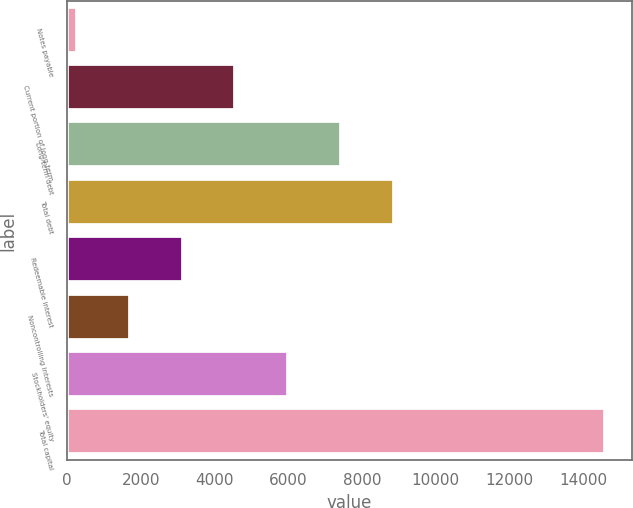<chart> <loc_0><loc_0><loc_500><loc_500><bar_chart><fcel>Notes payable<fcel>Current portion of long-term<fcel>Long-term debt<fcel>Total debt<fcel>Redeemable interest<fcel>Noncontrolling interests<fcel>Stockholders' equity<fcel>Total capital<nl><fcel>269.8<fcel>4563.94<fcel>7426.7<fcel>8858.08<fcel>3132.56<fcel>1701.18<fcel>5995.32<fcel>14583.6<nl></chart> 